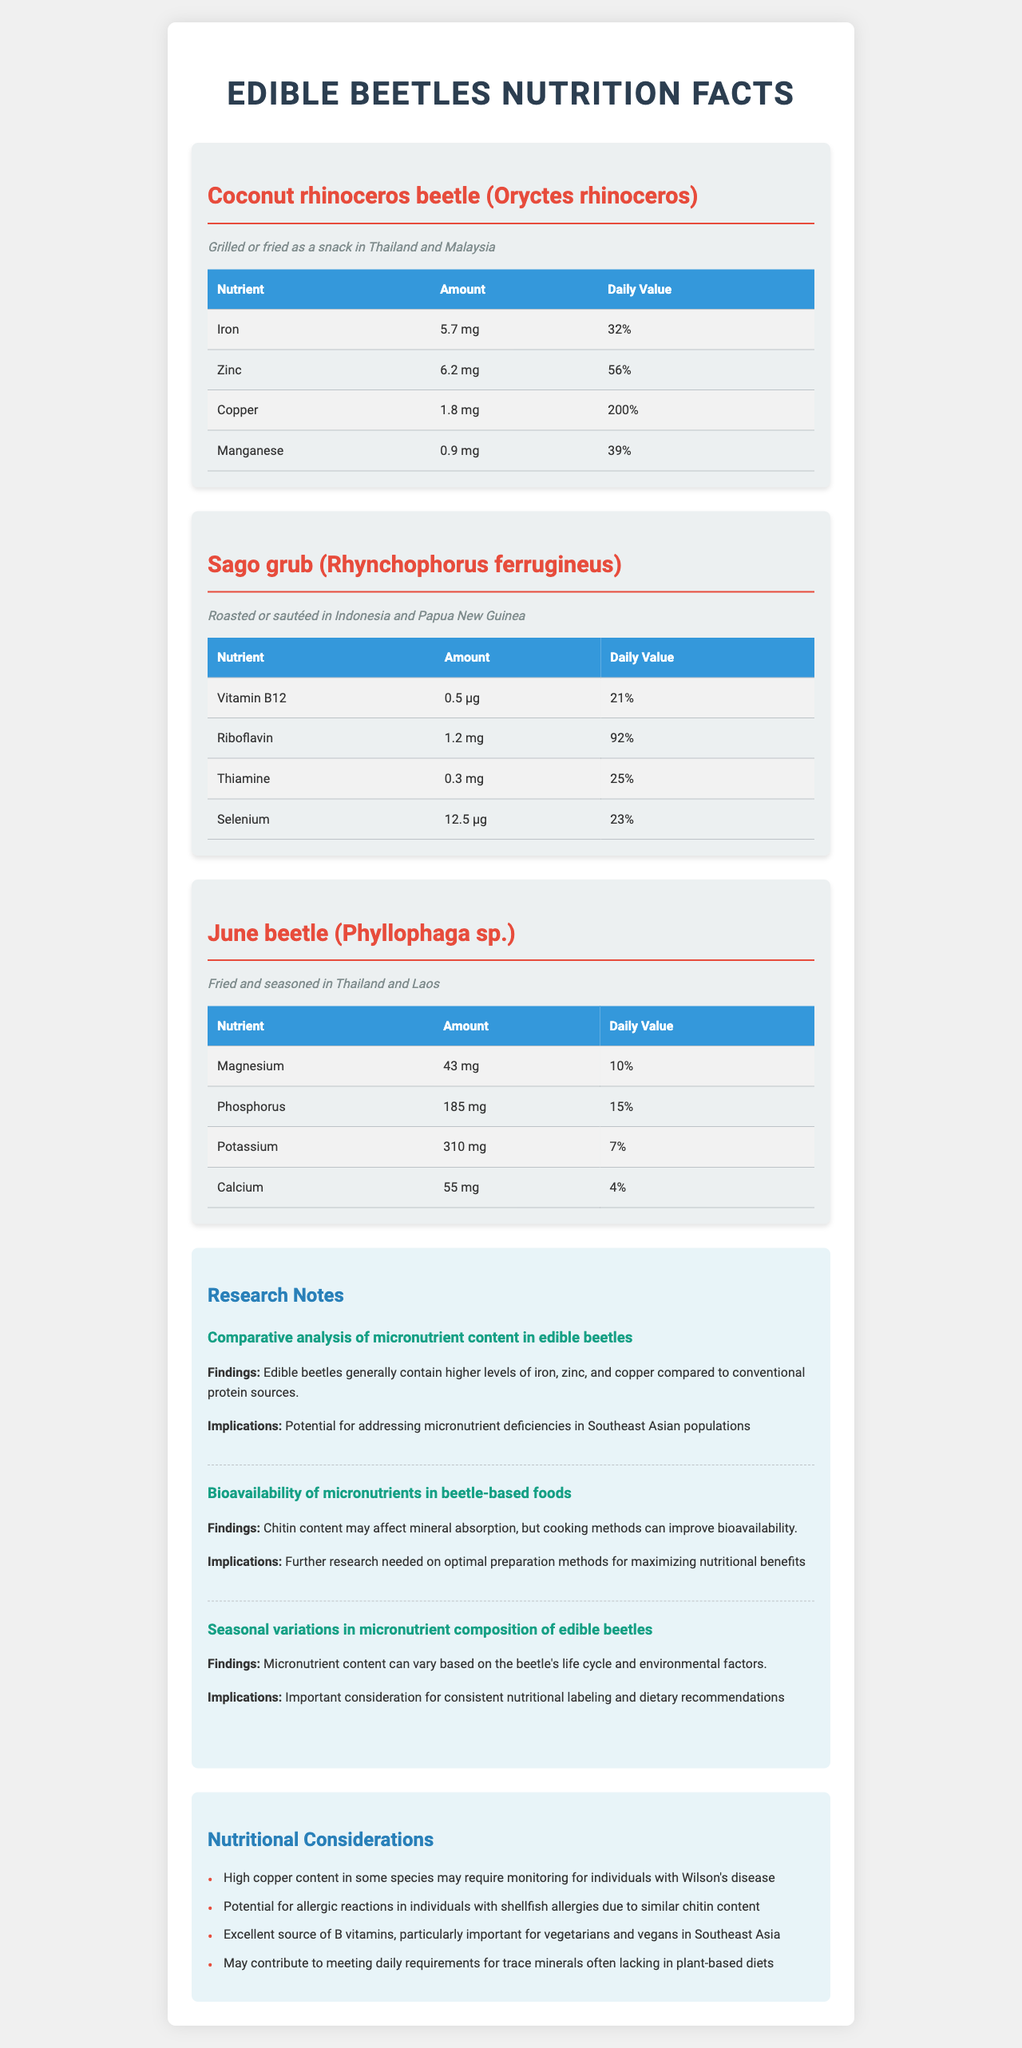what is the serving size for Coconut rhinoceros beetle? The serving size is listed in the data for Coconut rhinoceros beetle (Oryctes rhinoceros).
Answer: 100g how much Iron does the Sago grub contain? The nutritional data for Sago grub (Rhynchophorus ferrugineus) does not list Iron; it lists Vitamin B12, Riboflavin, Thiamine, and Selenium.
Answer: None what is the daily value percentage of Copper in Coconut rhinoceros beetle? The document states the Copper content is 1.8 mg, which is 200% of the daily value.
Answer: 200% which beetle contains the most Magnesium? The June beetle contains 43 mg of Magnesium, which is the highest among the listed beetles.
Answer: June beetle (Phyllophaga sp.) Summarize the potential health implications of consuming edible beetles listed in the document. Consuming edible beetles like Coconut rhinoceros beetle, Sago grub, and June beetle can provide significant amounts of micronutrients such as Iron, Zinc, Copper, Vitamin B12, and others, making them beneficial for addressing nutrient deficiencies. However, high Copper content requires monitoring for individuals with Wilson's disease, and potential allergic reactions are possible for individuals with shellfish allergies.
Answer: Health benefits and potential risks. what is the culinary use of the June beetle? The document mentions that the June beetle is fried and seasoned in Thailand and Laos.
Answer: Fried and seasoned in Thailand and Laos which of the following beetles has the highest daily value percentage for Riboflavin? 
A. Coconut rhinoceros beetle (Oryctes rhinoceros)
B. Sago grub (Rhynchophorus ferrugineus)
C. June beetle (Phyllophaga sp.) The Sago grub contains 1.2 mg of Riboflavin, which is 92% of the daily value, the highest among the listed beetles.
Answer: B True or False: All the edible beetles mentioned in the document have some amount of Selenium. Only the Sago grub contains Selenium (12.5 μg).
Answer: False which beetle contains Phosphorus and what amount? The June beetle contains 185 mg of Phosphorus according to the document.
Answer: June beetle (Phyllophaga sp.), 185 mg how does chitin content affect the nutritional benefits of edible beetles? The document mentions that chitin content may affect mineral absorption but cooking methods can improve bioavailability.
Answer: Affects mineral absorption can the amount of Iron in edible beetles be determined for the Sago grub? The document does not provide any information about Iron content in the Sago grub (Rhynchophorus ferrugineus).
Answer: Not enough information 